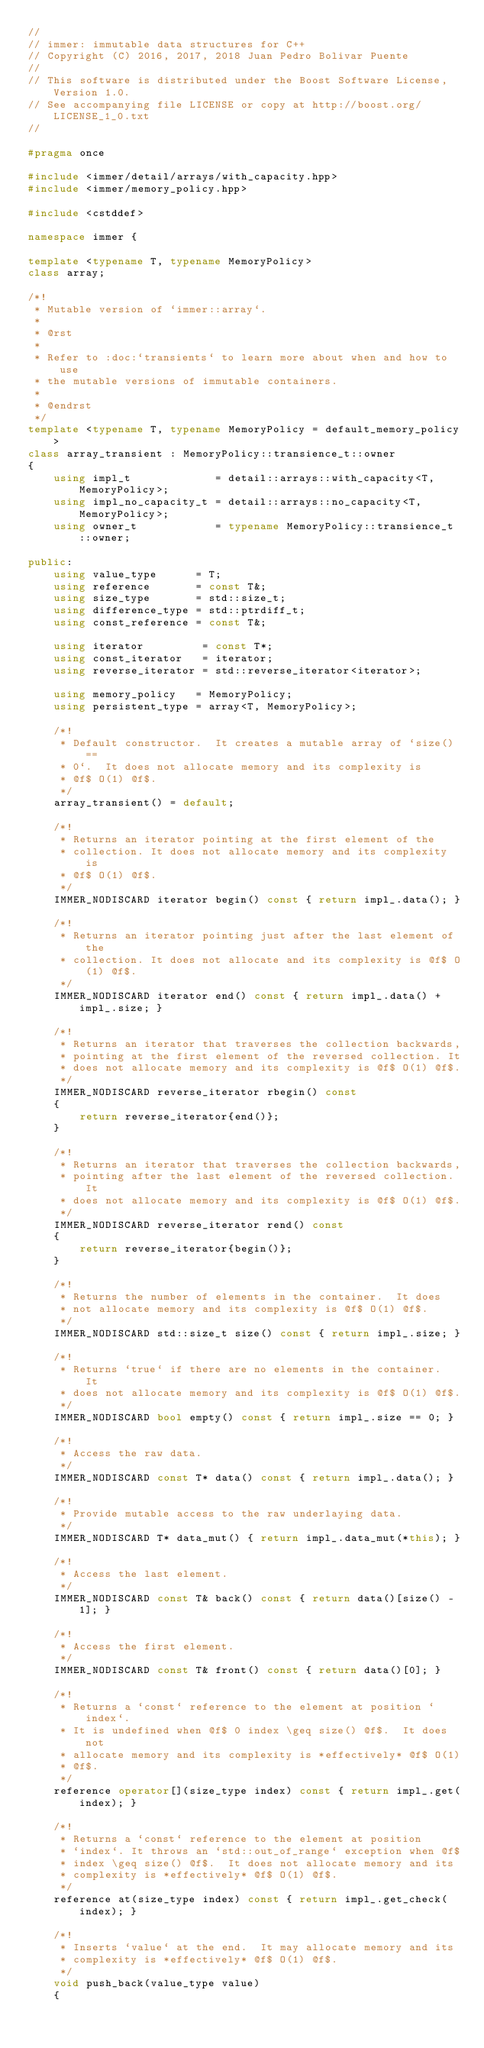<code> <loc_0><loc_0><loc_500><loc_500><_C++_>//
// immer: immutable data structures for C++
// Copyright (C) 2016, 2017, 2018 Juan Pedro Bolivar Puente
//
// This software is distributed under the Boost Software License, Version 1.0.
// See accompanying file LICENSE or copy at http://boost.org/LICENSE_1_0.txt
//

#pragma once

#include <immer/detail/arrays/with_capacity.hpp>
#include <immer/memory_policy.hpp>

#include <cstddef>

namespace immer {

template <typename T, typename MemoryPolicy>
class array;

/*!
 * Mutable version of `immer::array`.
 *
 * @rst
 *
 * Refer to :doc:`transients` to learn more about when and how to use
 * the mutable versions of immutable containers.
 *
 * @endrst
 */
template <typename T, typename MemoryPolicy = default_memory_policy>
class array_transient : MemoryPolicy::transience_t::owner
{
    using impl_t             = detail::arrays::with_capacity<T, MemoryPolicy>;
    using impl_no_capacity_t = detail::arrays::no_capacity<T, MemoryPolicy>;
    using owner_t            = typename MemoryPolicy::transience_t::owner;

public:
    using value_type      = T;
    using reference       = const T&;
    using size_type       = std::size_t;
    using difference_type = std::ptrdiff_t;
    using const_reference = const T&;

    using iterator         = const T*;
    using const_iterator   = iterator;
    using reverse_iterator = std::reverse_iterator<iterator>;

    using memory_policy   = MemoryPolicy;
    using persistent_type = array<T, MemoryPolicy>;

    /*!
     * Default constructor.  It creates a mutable array of `size() ==
     * 0`.  It does not allocate memory and its complexity is
     * @f$ O(1) @f$.
     */
    array_transient() = default;

    /*!
     * Returns an iterator pointing at the first element of the
     * collection. It does not allocate memory and its complexity is
     * @f$ O(1) @f$.
     */
    IMMER_NODISCARD iterator begin() const { return impl_.data(); }

    /*!
     * Returns an iterator pointing just after the last element of the
     * collection. It does not allocate and its complexity is @f$ O(1) @f$.
     */
    IMMER_NODISCARD iterator end() const { return impl_.data() + impl_.size; }

    /*!
     * Returns an iterator that traverses the collection backwards,
     * pointing at the first element of the reversed collection. It
     * does not allocate memory and its complexity is @f$ O(1) @f$.
     */
    IMMER_NODISCARD reverse_iterator rbegin() const
    {
        return reverse_iterator{end()};
    }

    /*!
     * Returns an iterator that traverses the collection backwards,
     * pointing after the last element of the reversed collection. It
     * does not allocate memory and its complexity is @f$ O(1) @f$.
     */
    IMMER_NODISCARD reverse_iterator rend() const
    {
        return reverse_iterator{begin()};
    }

    /*!
     * Returns the number of elements in the container.  It does
     * not allocate memory and its complexity is @f$ O(1) @f$.
     */
    IMMER_NODISCARD std::size_t size() const { return impl_.size; }

    /*!
     * Returns `true` if there are no elements in the container.  It
     * does not allocate memory and its complexity is @f$ O(1) @f$.
     */
    IMMER_NODISCARD bool empty() const { return impl_.size == 0; }

    /*!
     * Access the raw data.
     */
    IMMER_NODISCARD const T* data() const { return impl_.data(); }

    /*!
     * Provide mutable access to the raw underlaying data.
     */
    IMMER_NODISCARD T* data_mut() { return impl_.data_mut(*this); }

    /*!
     * Access the last element.
     */
    IMMER_NODISCARD const T& back() const { return data()[size() - 1]; }

    /*!
     * Access the first element.
     */
    IMMER_NODISCARD const T& front() const { return data()[0]; }

    /*!
     * Returns a `const` reference to the element at position `index`.
     * It is undefined when @f$ 0 index \geq size() @f$.  It does not
     * allocate memory and its complexity is *effectively* @f$ O(1)
     * @f$.
     */
    reference operator[](size_type index) const { return impl_.get(index); }

    /*!
     * Returns a `const` reference to the element at position
     * `index`. It throws an `std::out_of_range` exception when @f$
     * index \geq size() @f$.  It does not allocate memory and its
     * complexity is *effectively* @f$ O(1) @f$.
     */
    reference at(size_type index) const { return impl_.get_check(index); }

    /*!
     * Inserts `value` at the end.  It may allocate memory and its
     * complexity is *effectively* @f$ O(1) @f$.
     */
    void push_back(value_type value)
    {</code> 